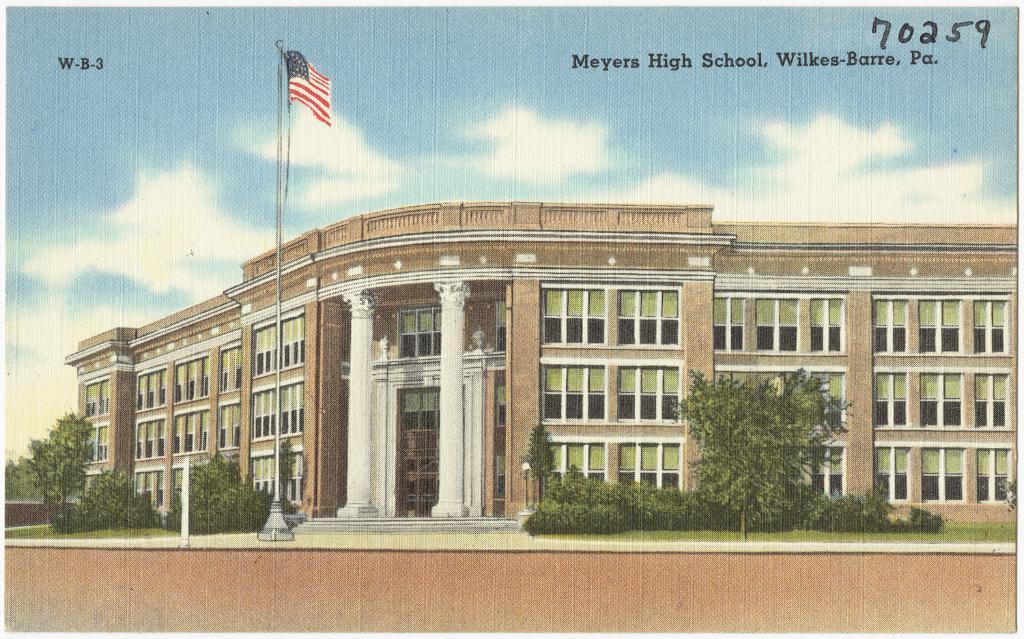Please provide a concise description of this image. This is a photo. In this picture we can see a building, windows, pillars, door, trees, poles, flag, grass. At the bottom of the image we can see a wall. At the top of the image we can see the text and clouds are present in the sky. 